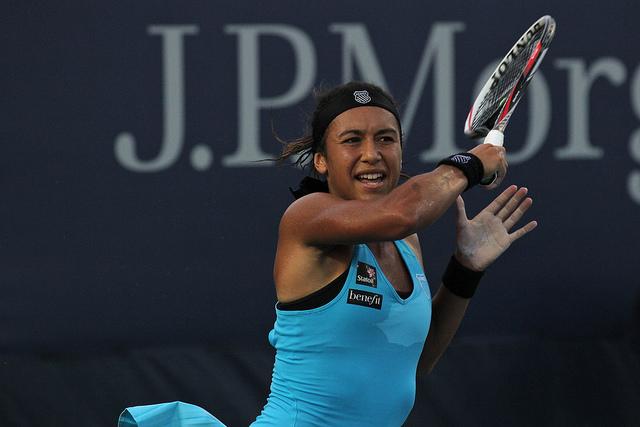What sport is this lady playing?
Give a very brief answer. Tennis. Who is a sponsor of this event?
Quick response, please. Jp morgan. What color is her headband?
Give a very brief answer. Black. 